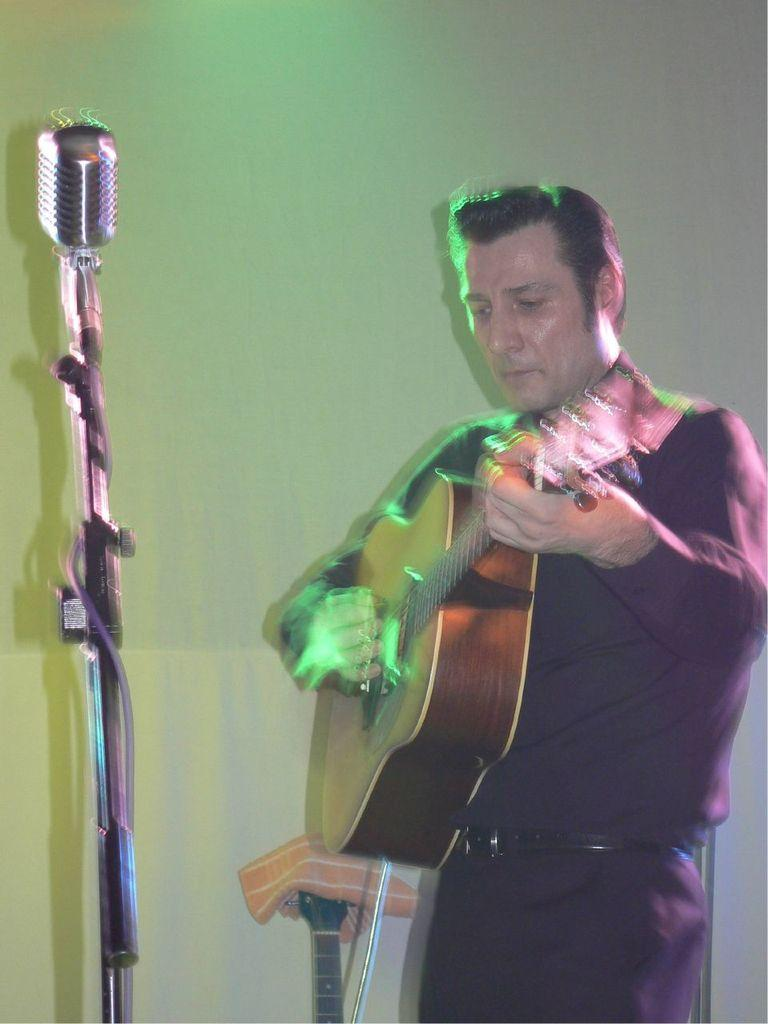What is the man in the image doing? The man is playing the guitar. What object is present in the image that is commonly used for amplifying sound? There is a microphone in the image. What type of engine can be seen powering the crow in the image? There is no crow or engine present in the image. 